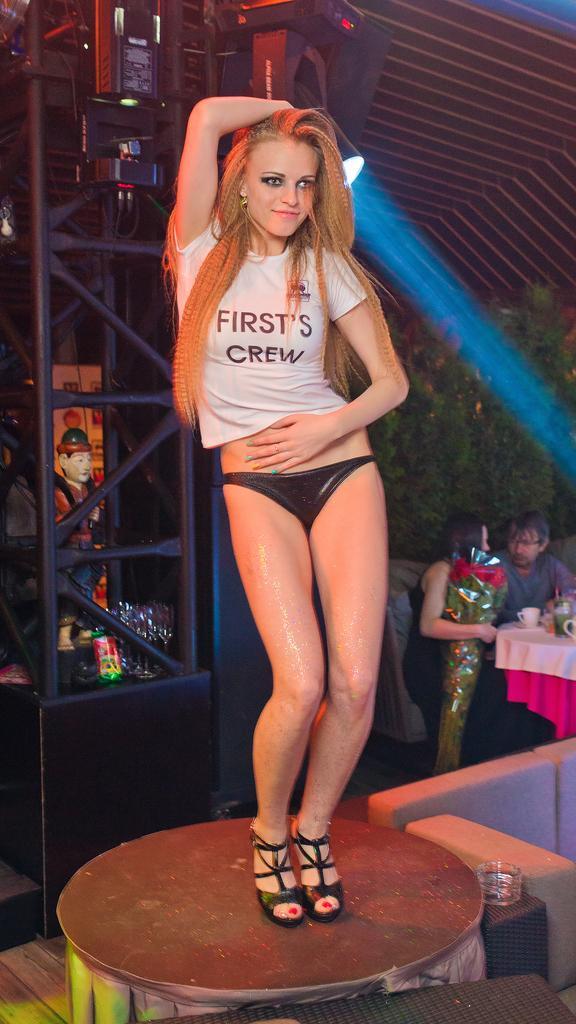In one or two sentences, can you explain what this image depicts? There is a women with white t- shirt and black heels, she is standing on a table. At the back there are two people sitting on a chair, she is holding a bouquet. There is a cup and bottle on a table, table is covered with white and pink cloth and at the background there is a tree. 